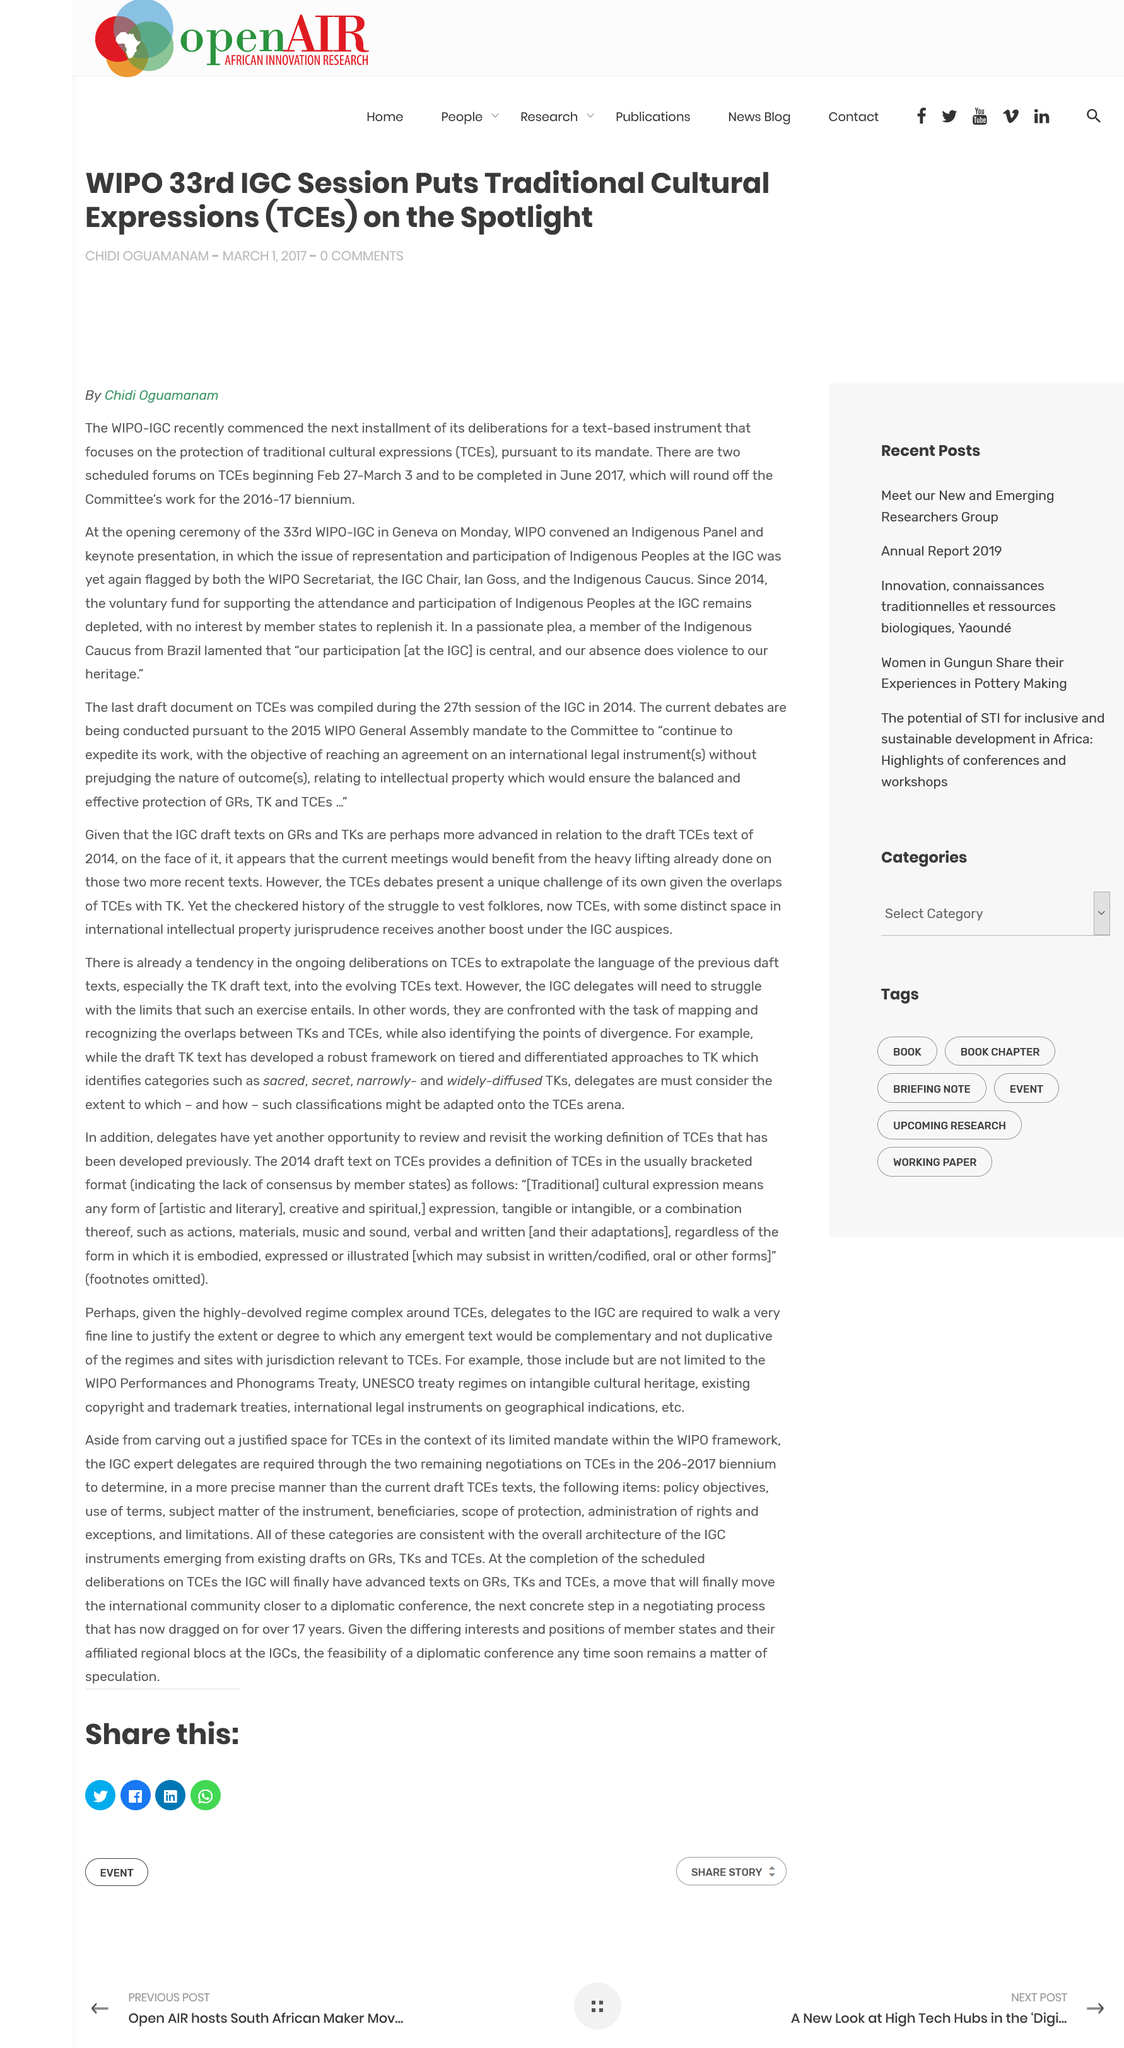Identify some key points in this picture. The two scheduled forums on TCEs are occurring between February 27 and March 3. The article titled "WIPO 33rd IGC Sessions Puts Traditional Cultural Expressions (TCEs) on the Spotlight" was written by Chidi Oguamanam. The completion of the two scheduled forums on TCEs is expected to be finished in June 2017. 